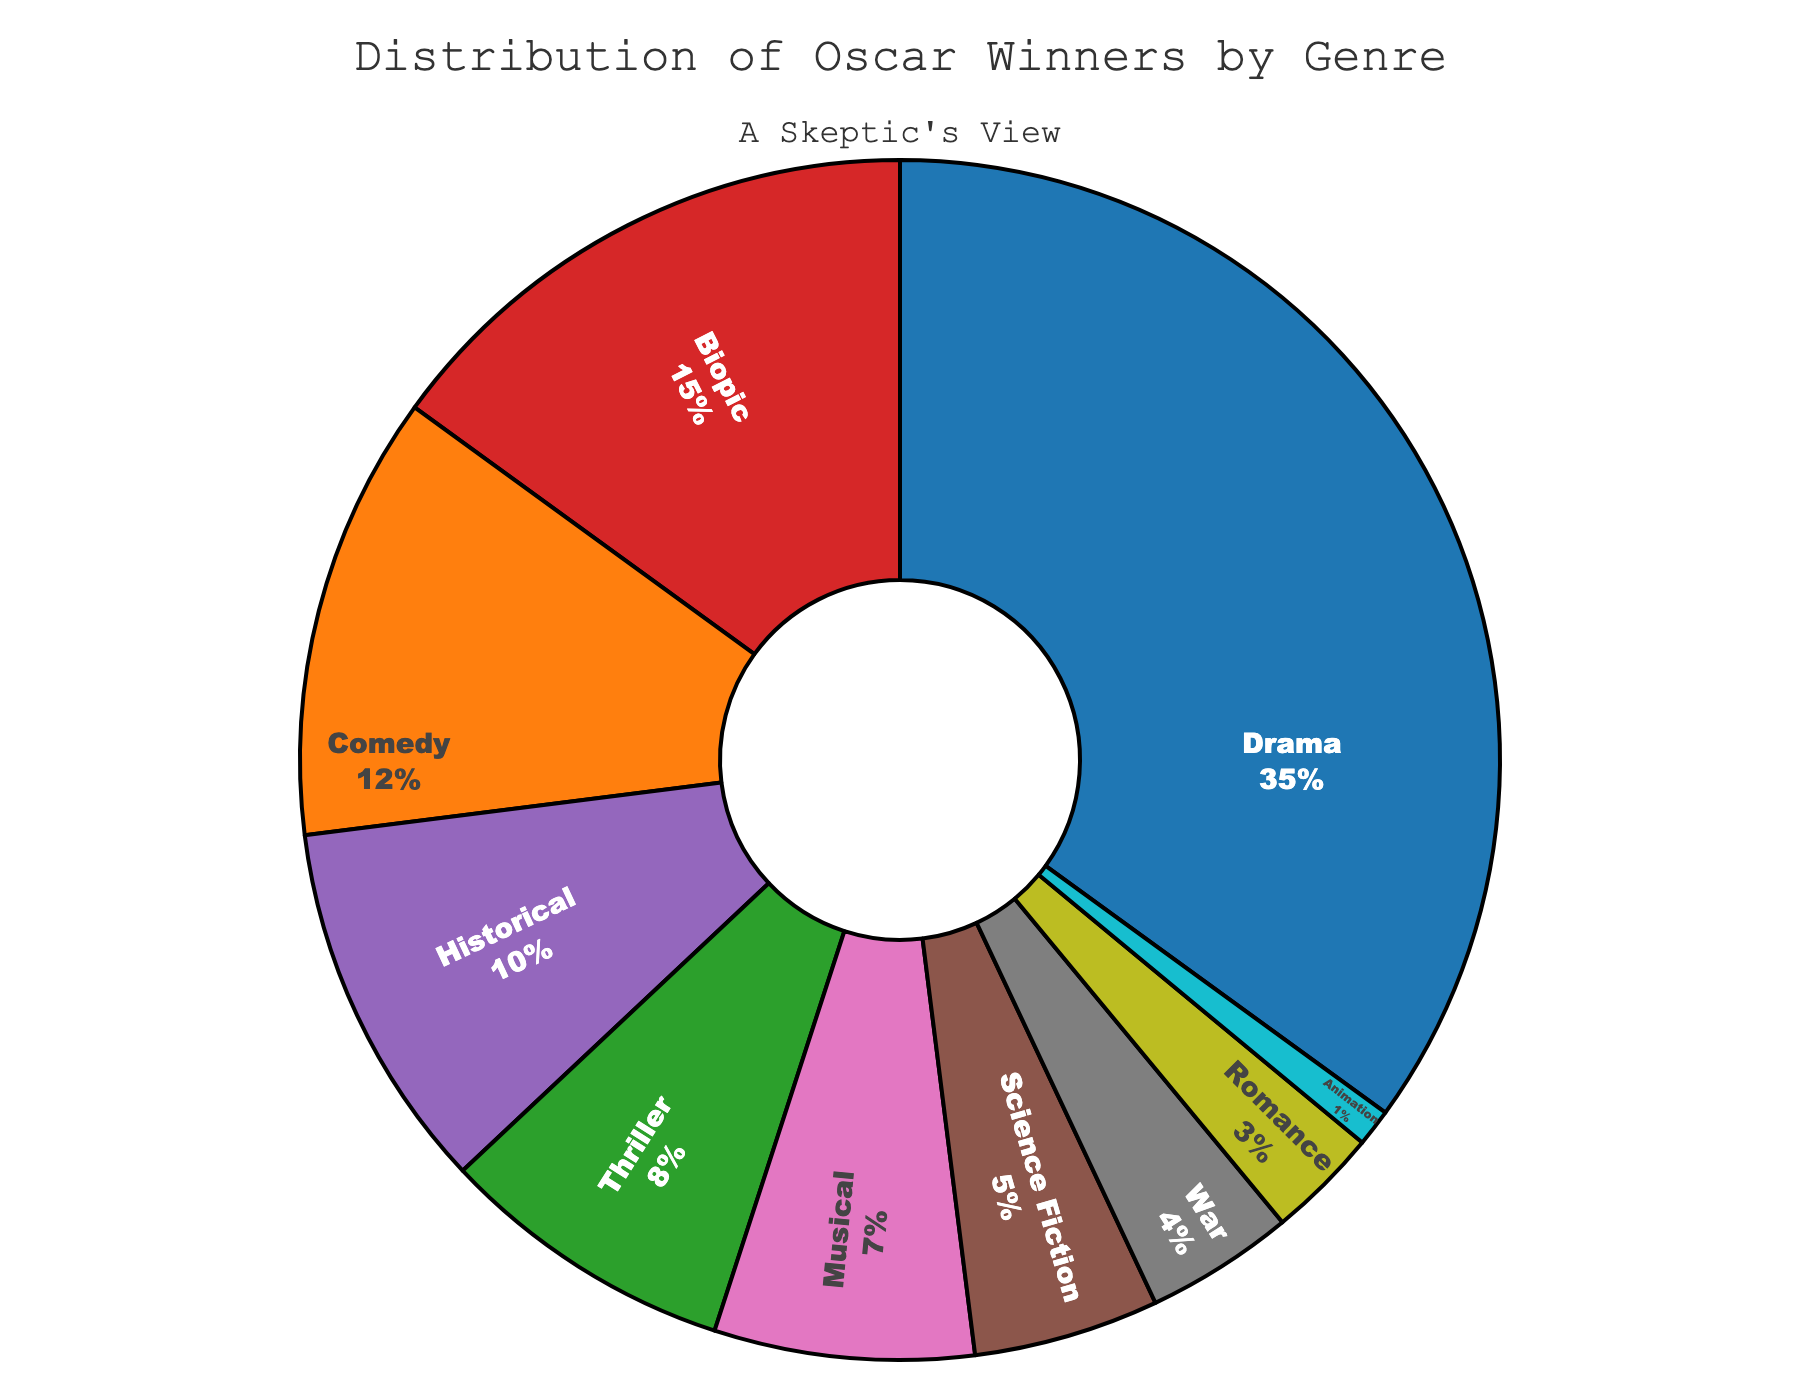what genre has the highest percentage of Oscar winners in the past decade? To determine the genre with the highest percentage, look at the figure and identify the genre with the largest portion of the pie chart. Drama is the largest section in the chart.
Answer: Drama Which genre has the second-highest percentage of Oscar winners? By referring to the pie chart, locate the second-largest section after Drama. Biopic is the second-largest section.
Answer: Biopic What is the combined percentage of Comedy and Science Fiction in the distribution of Oscar winners? Adding the percentage of Comedy (12%) and Science Fiction (5%) gives the combined percentage: 12 + 5 = 17%
Answer: 17% Which genre has a smaller proportion of winners than Musical but larger than Animation? Musical has 7%, and Animation has 1%. The genre with a proportion between these values is War at 4%.
Answer: War What is the total percentage of genres with less than 10% representation? Sum the percentages of Thriller (8%), Science Fiction (5%), Musical (7%), War (4%), Romance (3%), and Animation (1%): 8 + 5 + 7 + 4 + 3 + 1 = 28%
Answer: 28% If you subtract the percentage of Romance from Biopic, what is the result? Biopic has 15%, and Romance has 3%. Subtracting these gives: 15 - 3 = 12%
Answer: 12% Which genre has a greater percentage, Historical or Musical? Comparing the two segments, Historical has 10%, and Musical has 7%. Historical is greater.
Answer: Historical What is the visual color associated with the Science Fiction segment? Looking at the pie chart, identify the color associated with the Science Fiction wedge. It is green.
Answer: Green Is the percentage of Oscar winners for War greater or less than the percentage for Thriller? From the pie chart, Thriller is 8%, and War is 4%. Therefore, War is less.
Answer: Less What percentage of the distribution is not Drama, Biopic, or Historical? Subtracting Drama (35%), Biopic (15%), and Historical (10%) from 100% gives: 100 - 35 - 15 - 10 = 40%
Answer: 40% 